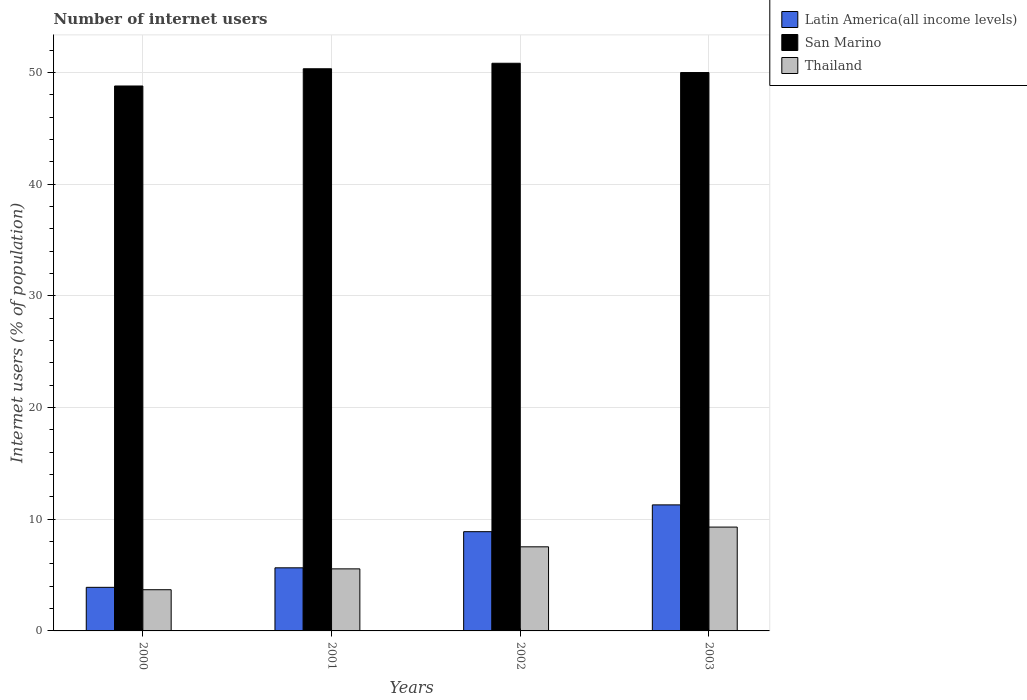How many groups of bars are there?
Your answer should be very brief. 4. Are the number of bars on each tick of the X-axis equal?
Ensure brevity in your answer.  Yes. How many bars are there on the 4th tick from the right?
Keep it short and to the point. 3. What is the number of internet users in Latin America(all income levels) in 2003?
Keep it short and to the point. 11.29. Across all years, what is the maximum number of internet users in Thailand?
Provide a short and direct response. 9.3. Across all years, what is the minimum number of internet users in Thailand?
Provide a short and direct response. 3.69. What is the total number of internet users in San Marino in the graph?
Your answer should be compact. 199.98. What is the difference between the number of internet users in San Marino in 2001 and that in 2003?
Give a very brief answer. 0.34. What is the difference between the number of internet users in Latin America(all income levels) in 2000 and the number of internet users in Thailand in 2003?
Your response must be concise. -5.4. What is the average number of internet users in San Marino per year?
Keep it short and to the point. 49.99. In the year 2002, what is the difference between the number of internet users in Thailand and number of internet users in San Marino?
Your response must be concise. -43.3. What is the ratio of the number of internet users in San Marino in 2000 to that in 2001?
Keep it short and to the point. 0.97. Is the number of internet users in San Marino in 2000 less than that in 2001?
Offer a terse response. Yes. Is the difference between the number of internet users in Thailand in 2000 and 2002 greater than the difference between the number of internet users in San Marino in 2000 and 2002?
Make the answer very short. No. What is the difference between the highest and the second highest number of internet users in Latin America(all income levels)?
Offer a very short reply. 2.4. What is the difference between the highest and the lowest number of internet users in San Marino?
Ensure brevity in your answer.  2.04. What does the 1st bar from the left in 2000 represents?
Keep it short and to the point. Latin America(all income levels). What does the 3rd bar from the right in 2003 represents?
Offer a terse response. Latin America(all income levels). Is it the case that in every year, the sum of the number of internet users in Latin America(all income levels) and number of internet users in San Marino is greater than the number of internet users in Thailand?
Offer a very short reply. Yes. Are the values on the major ticks of Y-axis written in scientific E-notation?
Make the answer very short. No. Does the graph contain any zero values?
Your answer should be compact. No. Does the graph contain grids?
Provide a succinct answer. Yes. Where does the legend appear in the graph?
Your answer should be compact. Top right. How many legend labels are there?
Give a very brief answer. 3. How are the legend labels stacked?
Offer a very short reply. Vertical. What is the title of the graph?
Provide a succinct answer. Number of internet users. What is the label or title of the Y-axis?
Keep it short and to the point. Internet users (% of population). What is the Internet users (% of population) in Latin America(all income levels) in 2000?
Your answer should be compact. 3.9. What is the Internet users (% of population) of San Marino in 2000?
Your answer should be compact. 48.8. What is the Internet users (% of population) of Thailand in 2000?
Give a very brief answer. 3.69. What is the Internet users (% of population) in Latin America(all income levels) in 2001?
Keep it short and to the point. 5.65. What is the Internet users (% of population) in San Marino in 2001?
Offer a very short reply. 50.34. What is the Internet users (% of population) in Thailand in 2001?
Provide a short and direct response. 5.56. What is the Internet users (% of population) of Latin America(all income levels) in 2002?
Offer a very short reply. 8.89. What is the Internet users (% of population) in San Marino in 2002?
Your answer should be compact. 50.83. What is the Internet users (% of population) of Thailand in 2002?
Keep it short and to the point. 7.53. What is the Internet users (% of population) of Latin America(all income levels) in 2003?
Offer a very short reply. 11.29. What is the Internet users (% of population) of San Marino in 2003?
Your answer should be very brief. 50. What is the Internet users (% of population) of Thailand in 2003?
Provide a succinct answer. 9.3. Across all years, what is the maximum Internet users (% of population) in Latin America(all income levels)?
Provide a short and direct response. 11.29. Across all years, what is the maximum Internet users (% of population) in San Marino?
Ensure brevity in your answer.  50.83. Across all years, what is the maximum Internet users (% of population) in Thailand?
Offer a terse response. 9.3. Across all years, what is the minimum Internet users (% of population) in Latin America(all income levels)?
Your answer should be very brief. 3.9. Across all years, what is the minimum Internet users (% of population) of San Marino?
Your response must be concise. 48.8. Across all years, what is the minimum Internet users (% of population) of Thailand?
Offer a terse response. 3.69. What is the total Internet users (% of population) in Latin America(all income levels) in the graph?
Provide a succinct answer. 29.73. What is the total Internet users (% of population) in San Marino in the graph?
Your response must be concise. 199.98. What is the total Internet users (% of population) of Thailand in the graph?
Provide a succinct answer. 26.08. What is the difference between the Internet users (% of population) of Latin America(all income levels) in 2000 and that in 2001?
Provide a succinct answer. -1.75. What is the difference between the Internet users (% of population) of San Marino in 2000 and that in 2001?
Ensure brevity in your answer.  -1.54. What is the difference between the Internet users (% of population) of Thailand in 2000 and that in 2001?
Provide a short and direct response. -1.87. What is the difference between the Internet users (% of population) of Latin America(all income levels) in 2000 and that in 2002?
Offer a terse response. -4.98. What is the difference between the Internet users (% of population) in San Marino in 2000 and that in 2002?
Make the answer very short. -2.04. What is the difference between the Internet users (% of population) of Thailand in 2000 and that in 2002?
Provide a short and direct response. -3.84. What is the difference between the Internet users (% of population) of Latin America(all income levels) in 2000 and that in 2003?
Make the answer very short. -7.38. What is the difference between the Internet users (% of population) in San Marino in 2000 and that in 2003?
Offer a very short reply. -1.2. What is the difference between the Internet users (% of population) of Thailand in 2000 and that in 2003?
Keep it short and to the point. -5.61. What is the difference between the Internet users (% of population) of Latin America(all income levels) in 2001 and that in 2002?
Your answer should be compact. -3.24. What is the difference between the Internet users (% of population) of San Marino in 2001 and that in 2002?
Offer a terse response. -0.49. What is the difference between the Internet users (% of population) in Thailand in 2001 and that in 2002?
Keep it short and to the point. -1.97. What is the difference between the Internet users (% of population) of Latin America(all income levels) in 2001 and that in 2003?
Provide a succinct answer. -5.64. What is the difference between the Internet users (% of population) in San Marino in 2001 and that in 2003?
Your answer should be very brief. 0.34. What is the difference between the Internet users (% of population) in Thailand in 2001 and that in 2003?
Your answer should be compact. -3.74. What is the difference between the Internet users (% of population) of Latin America(all income levels) in 2002 and that in 2003?
Your response must be concise. -2.4. What is the difference between the Internet users (% of population) of San Marino in 2002 and that in 2003?
Make the answer very short. 0.83. What is the difference between the Internet users (% of population) of Thailand in 2002 and that in 2003?
Your response must be concise. -1.77. What is the difference between the Internet users (% of population) of Latin America(all income levels) in 2000 and the Internet users (% of population) of San Marino in 2001?
Your answer should be very brief. -46.44. What is the difference between the Internet users (% of population) in Latin America(all income levels) in 2000 and the Internet users (% of population) in Thailand in 2001?
Ensure brevity in your answer.  -1.65. What is the difference between the Internet users (% of population) in San Marino in 2000 and the Internet users (% of population) in Thailand in 2001?
Offer a terse response. 43.24. What is the difference between the Internet users (% of population) of Latin America(all income levels) in 2000 and the Internet users (% of population) of San Marino in 2002?
Your answer should be compact. -46.93. What is the difference between the Internet users (% of population) of Latin America(all income levels) in 2000 and the Internet users (% of population) of Thailand in 2002?
Offer a very short reply. -3.63. What is the difference between the Internet users (% of population) in San Marino in 2000 and the Internet users (% of population) in Thailand in 2002?
Give a very brief answer. 41.27. What is the difference between the Internet users (% of population) in Latin America(all income levels) in 2000 and the Internet users (% of population) in San Marino in 2003?
Offer a very short reply. -46.1. What is the difference between the Internet users (% of population) in Latin America(all income levels) in 2000 and the Internet users (% of population) in Thailand in 2003?
Offer a terse response. -5.4. What is the difference between the Internet users (% of population) in San Marino in 2000 and the Internet users (% of population) in Thailand in 2003?
Provide a succinct answer. 39.5. What is the difference between the Internet users (% of population) of Latin America(all income levels) in 2001 and the Internet users (% of population) of San Marino in 2002?
Your answer should be very brief. -45.18. What is the difference between the Internet users (% of population) in Latin America(all income levels) in 2001 and the Internet users (% of population) in Thailand in 2002?
Give a very brief answer. -1.88. What is the difference between the Internet users (% of population) of San Marino in 2001 and the Internet users (% of population) of Thailand in 2002?
Give a very brief answer. 42.81. What is the difference between the Internet users (% of population) in Latin America(all income levels) in 2001 and the Internet users (% of population) in San Marino in 2003?
Provide a succinct answer. -44.35. What is the difference between the Internet users (% of population) of Latin America(all income levels) in 2001 and the Internet users (% of population) of Thailand in 2003?
Provide a short and direct response. -3.65. What is the difference between the Internet users (% of population) of San Marino in 2001 and the Internet users (% of population) of Thailand in 2003?
Offer a very short reply. 41.04. What is the difference between the Internet users (% of population) of Latin America(all income levels) in 2002 and the Internet users (% of population) of San Marino in 2003?
Offer a very short reply. -41.12. What is the difference between the Internet users (% of population) in Latin America(all income levels) in 2002 and the Internet users (% of population) in Thailand in 2003?
Provide a succinct answer. -0.41. What is the difference between the Internet users (% of population) of San Marino in 2002 and the Internet users (% of population) of Thailand in 2003?
Your answer should be compact. 41.54. What is the average Internet users (% of population) of Latin America(all income levels) per year?
Give a very brief answer. 7.43. What is the average Internet users (% of population) in San Marino per year?
Give a very brief answer. 49.99. What is the average Internet users (% of population) of Thailand per year?
Your answer should be compact. 6.52. In the year 2000, what is the difference between the Internet users (% of population) of Latin America(all income levels) and Internet users (% of population) of San Marino?
Offer a very short reply. -44.9. In the year 2000, what is the difference between the Internet users (% of population) in Latin America(all income levels) and Internet users (% of population) in Thailand?
Give a very brief answer. 0.21. In the year 2000, what is the difference between the Internet users (% of population) of San Marino and Internet users (% of population) of Thailand?
Ensure brevity in your answer.  45.11. In the year 2001, what is the difference between the Internet users (% of population) of Latin America(all income levels) and Internet users (% of population) of San Marino?
Provide a short and direct response. -44.69. In the year 2001, what is the difference between the Internet users (% of population) of Latin America(all income levels) and Internet users (% of population) of Thailand?
Keep it short and to the point. 0.09. In the year 2001, what is the difference between the Internet users (% of population) in San Marino and Internet users (% of population) in Thailand?
Provide a short and direct response. 44.79. In the year 2002, what is the difference between the Internet users (% of population) in Latin America(all income levels) and Internet users (% of population) in San Marino?
Offer a terse response. -41.95. In the year 2002, what is the difference between the Internet users (% of population) of Latin America(all income levels) and Internet users (% of population) of Thailand?
Offer a very short reply. 1.36. In the year 2002, what is the difference between the Internet users (% of population) of San Marino and Internet users (% of population) of Thailand?
Ensure brevity in your answer.  43.3. In the year 2003, what is the difference between the Internet users (% of population) in Latin America(all income levels) and Internet users (% of population) in San Marino?
Keep it short and to the point. -38.72. In the year 2003, what is the difference between the Internet users (% of population) of Latin America(all income levels) and Internet users (% of population) of Thailand?
Your answer should be very brief. 1.99. In the year 2003, what is the difference between the Internet users (% of population) in San Marino and Internet users (% of population) in Thailand?
Offer a very short reply. 40.7. What is the ratio of the Internet users (% of population) of Latin America(all income levels) in 2000 to that in 2001?
Keep it short and to the point. 0.69. What is the ratio of the Internet users (% of population) in San Marino in 2000 to that in 2001?
Make the answer very short. 0.97. What is the ratio of the Internet users (% of population) of Thailand in 2000 to that in 2001?
Your answer should be compact. 0.66. What is the ratio of the Internet users (% of population) of Latin America(all income levels) in 2000 to that in 2002?
Make the answer very short. 0.44. What is the ratio of the Internet users (% of population) in San Marino in 2000 to that in 2002?
Keep it short and to the point. 0.96. What is the ratio of the Internet users (% of population) in Thailand in 2000 to that in 2002?
Keep it short and to the point. 0.49. What is the ratio of the Internet users (% of population) in Latin America(all income levels) in 2000 to that in 2003?
Offer a very short reply. 0.35. What is the ratio of the Internet users (% of population) in San Marino in 2000 to that in 2003?
Keep it short and to the point. 0.98. What is the ratio of the Internet users (% of population) in Thailand in 2000 to that in 2003?
Your answer should be compact. 0.4. What is the ratio of the Internet users (% of population) of Latin America(all income levels) in 2001 to that in 2002?
Offer a terse response. 0.64. What is the ratio of the Internet users (% of population) in San Marino in 2001 to that in 2002?
Your answer should be very brief. 0.99. What is the ratio of the Internet users (% of population) of Thailand in 2001 to that in 2002?
Give a very brief answer. 0.74. What is the ratio of the Internet users (% of population) of Latin America(all income levels) in 2001 to that in 2003?
Ensure brevity in your answer.  0.5. What is the ratio of the Internet users (% of population) in San Marino in 2001 to that in 2003?
Make the answer very short. 1.01. What is the ratio of the Internet users (% of population) in Thailand in 2001 to that in 2003?
Offer a very short reply. 0.6. What is the ratio of the Internet users (% of population) of Latin America(all income levels) in 2002 to that in 2003?
Your response must be concise. 0.79. What is the ratio of the Internet users (% of population) in San Marino in 2002 to that in 2003?
Provide a short and direct response. 1.02. What is the ratio of the Internet users (% of population) of Thailand in 2002 to that in 2003?
Keep it short and to the point. 0.81. What is the difference between the highest and the second highest Internet users (% of population) in Latin America(all income levels)?
Give a very brief answer. 2.4. What is the difference between the highest and the second highest Internet users (% of population) in San Marino?
Offer a very short reply. 0.49. What is the difference between the highest and the second highest Internet users (% of population) of Thailand?
Your response must be concise. 1.77. What is the difference between the highest and the lowest Internet users (% of population) of Latin America(all income levels)?
Your answer should be very brief. 7.38. What is the difference between the highest and the lowest Internet users (% of population) of San Marino?
Ensure brevity in your answer.  2.04. What is the difference between the highest and the lowest Internet users (% of population) of Thailand?
Keep it short and to the point. 5.61. 